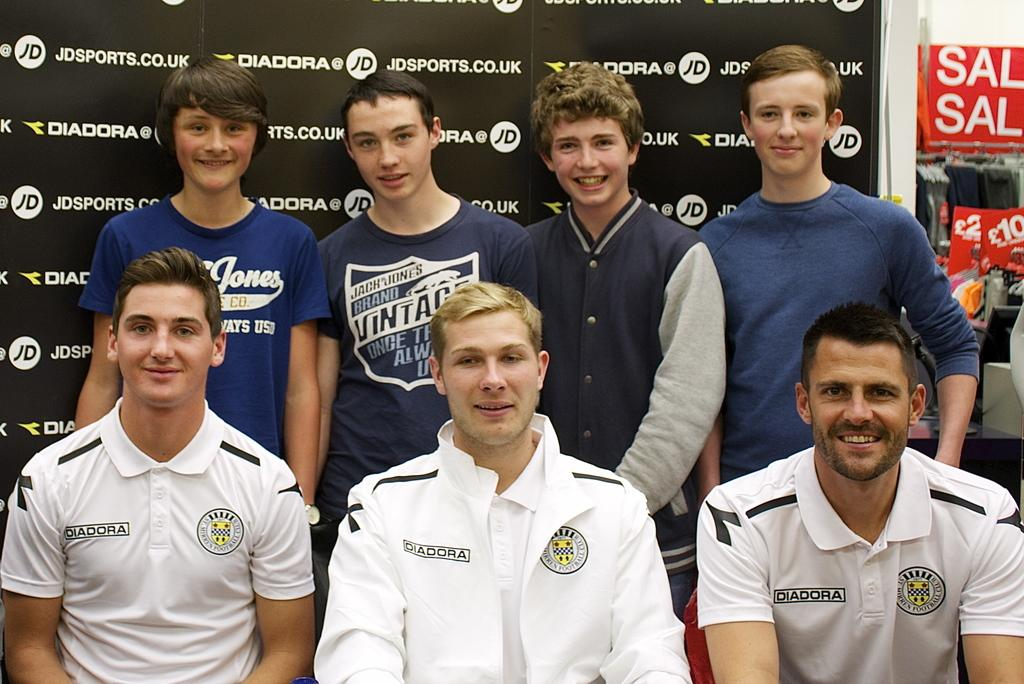<image>
Create a compact narrative representing the image presented. The men in the front row wear shirts with the word Diadora on them. 